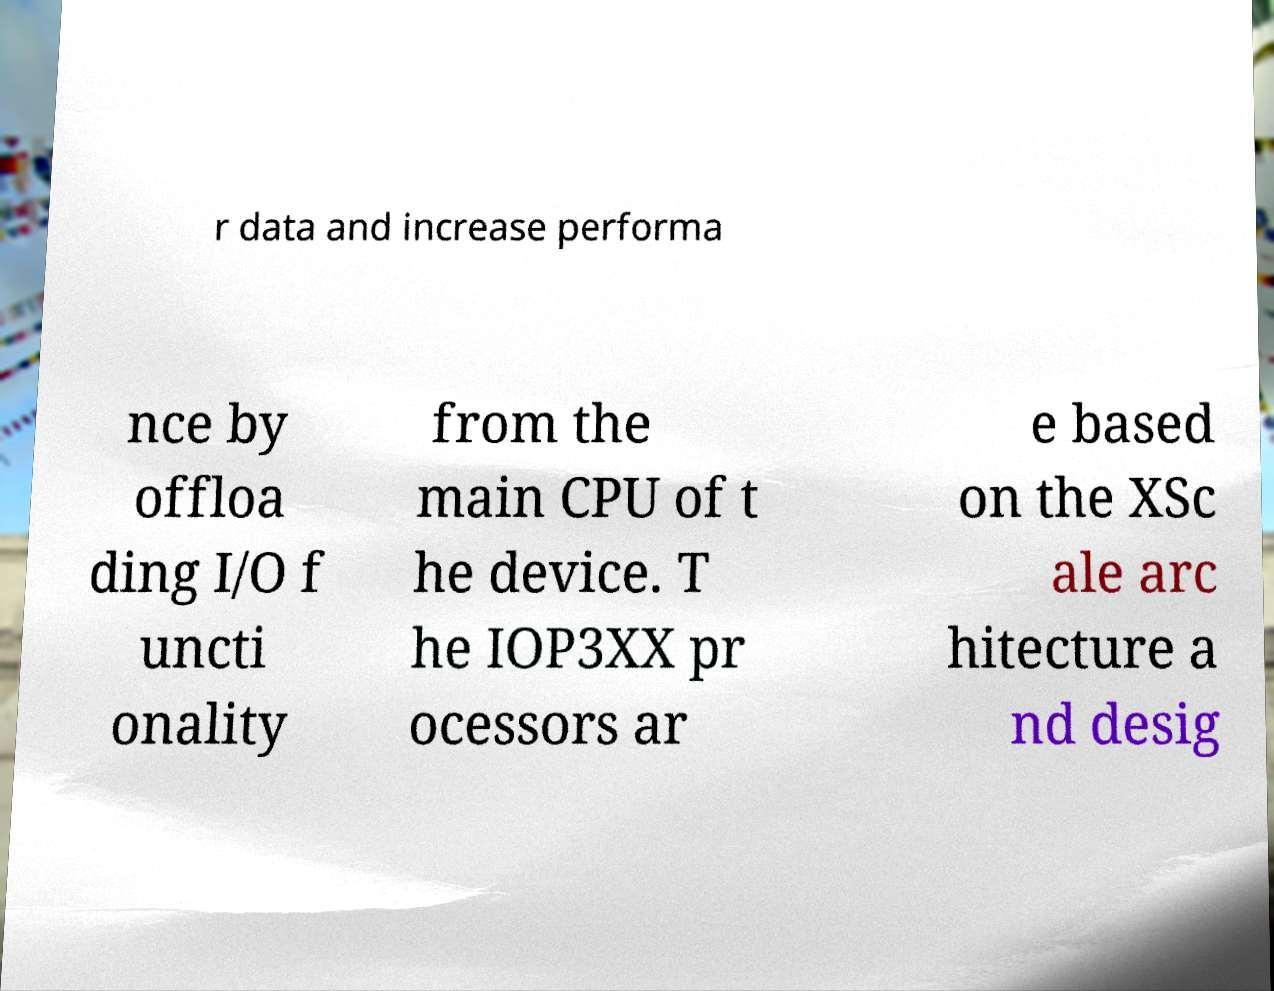For documentation purposes, I need the text within this image transcribed. Could you provide that? r data and increase performa nce by offloa ding I/O f uncti onality from the main CPU of t he device. T he IOP3XX pr ocessors ar e based on the XSc ale arc hitecture a nd desig 